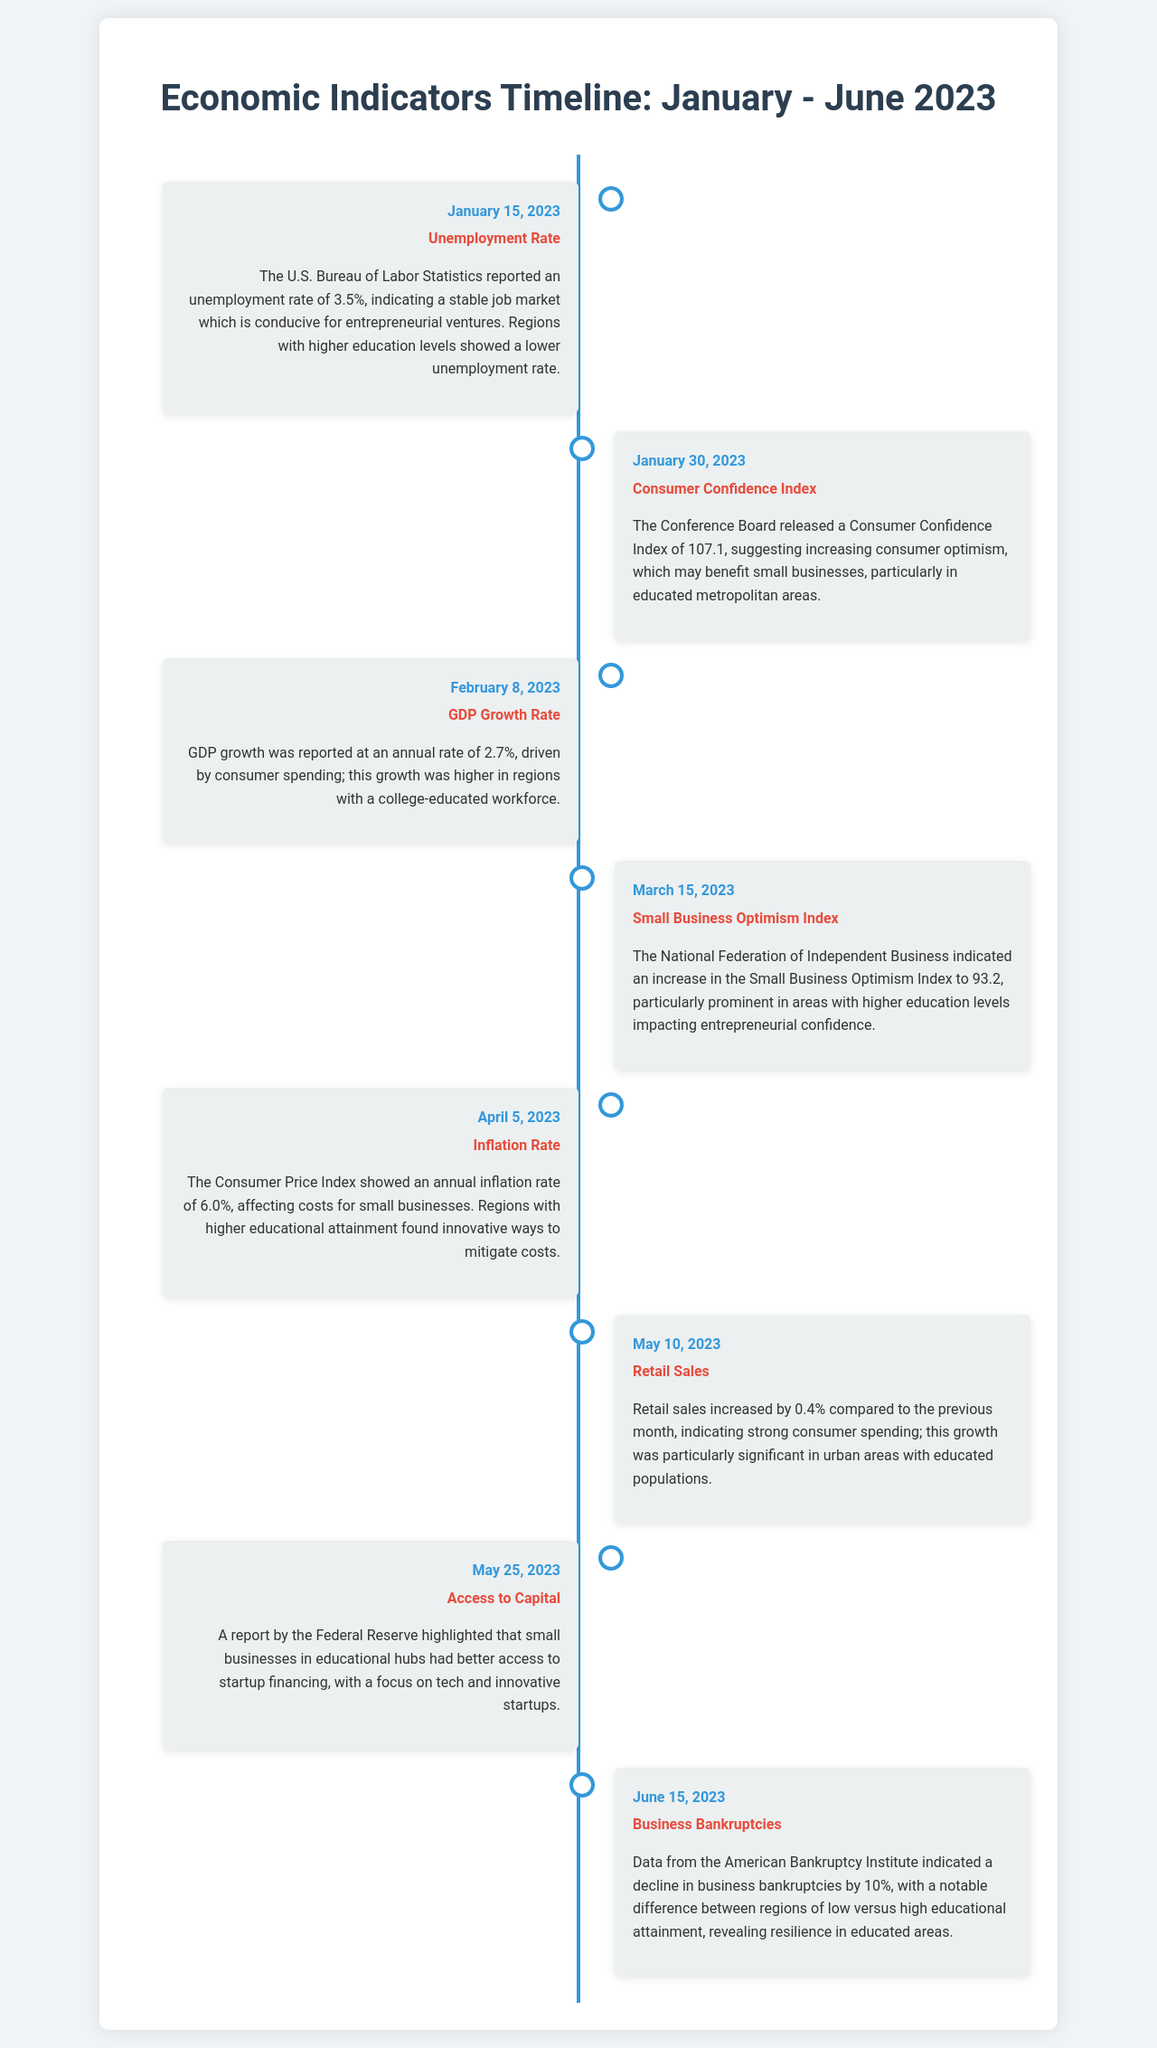What was the unemployment rate in January 2023? The unemployment rate reported was 3.5% on January 15, 2023.
Answer: 3.5% What is the Consumer Confidence Index value for January 2023? The Consumer Confidence Index was reported as 107.1 on January 30, 2023.
Answer: 107.1 What was the GDP growth rate reported in February 2023? The GDP growth rate was reported at an annual rate of 2.7% on February 8, 2023.
Answer: 2.7% What indicator increased to 93.2 in March 2023? The Small Business Optimism Index increased to 93.2 on March 15, 2023.
Answer: Small Business Optimism Index What is the annual inflation rate reported in April 2023? The annual inflation rate was reported at 6.0% on April 5, 2023.
Answer: 6.0% Which month saw a 0.4% increase in retail sales? Retail sales increased by 0.4% compared to the previous month in May 2023.
Answer: May What was highlighted regarding access to capital on May 25, 2023? There was better access to startup financing for small businesses in educational hubs on May 25, 2023.
Answer: Better access to startup financing What trend in business bankruptcies was reported in June 2023? There was a decline in business bankruptcies by 10% reported on June 15, 2023.
Answer: Decline by 10% 